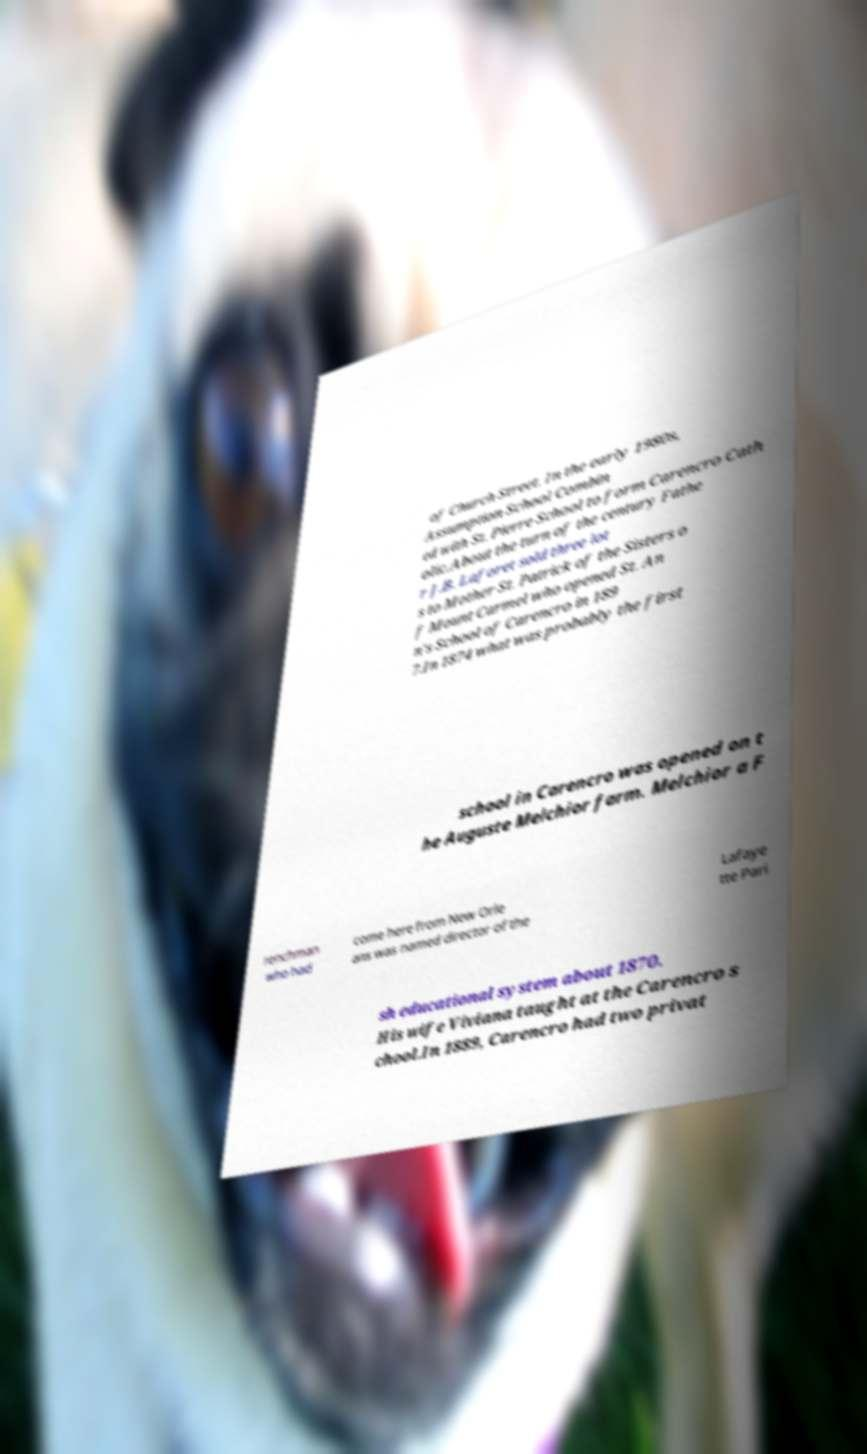What messages or text are displayed in this image? I need them in a readable, typed format. of Church Street. In the early 1980s, Assumption School Combin ed with St. Pierre School to form Carencro Cath olic.About the turn of the century Fathe r J.B. Laforet sold three lot s to Mother St. Patrick of the Sisters o f Mount Carmel who opened St. An n's School of Carencro in 189 7.In 1874 what was probably the first school in Carencro was opened on t he Auguste Melchior farm. Melchior a F renchman who had come here from New Orle ans was named director of the Lafaye tte Pari sh educational system about 1870. His wife Viviana taught at the Carencro s chool.In 1889, Carencro had two privat 